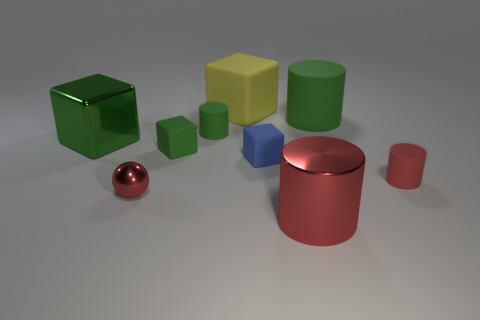Add 1 tiny green rubber cylinders. How many objects exist? 10 Subtract all cubes. How many objects are left? 5 Add 7 large purple matte cylinders. How many large purple matte cylinders exist? 7 Subtract 0 yellow cylinders. How many objects are left? 9 Subtract all tiny blue cylinders. Subtract all small objects. How many objects are left? 4 Add 7 big red things. How many big red things are left? 8 